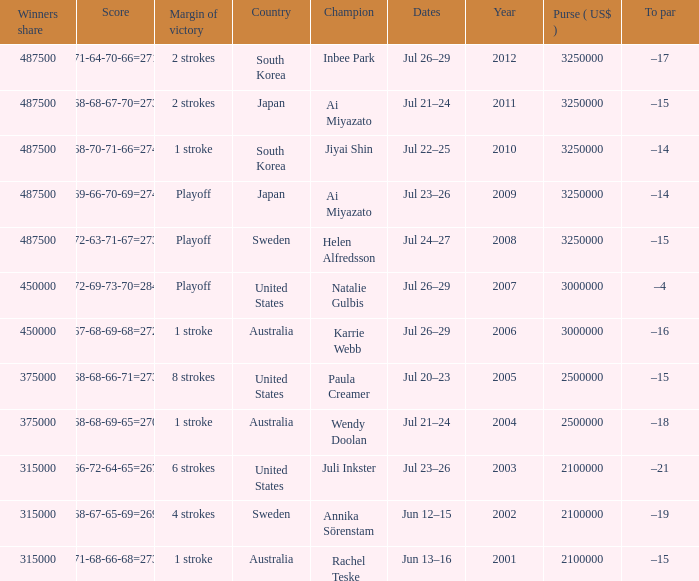What is the lowest year listed? 2001.0. 